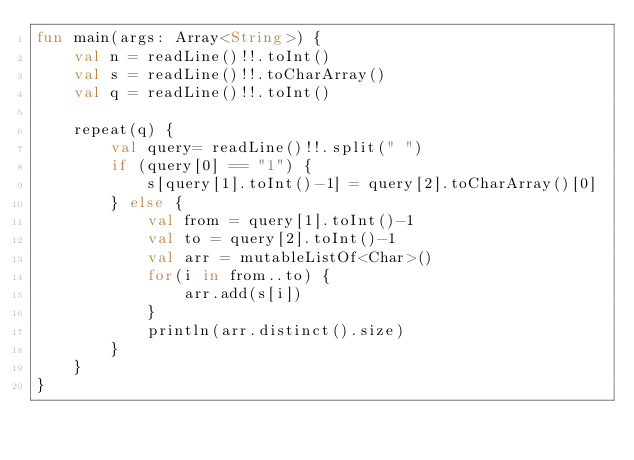Convert code to text. <code><loc_0><loc_0><loc_500><loc_500><_Kotlin_>fun main(args: Array<String>) {
    val n = readLine()!!.toInt()
    val s = readLine()!!.toCharArray()
    val q = readLine()!!.toInt()

    repeat(q) {
        val query= readLine()!!.split(" ")
        if (query[0] == "1") {
            s[query[1].toInt()-1] = query[2].toCharArray()[0]
        } else {
            val from = query[1].toInt()-1
            val to = query[2].toInt()-1
            val arr = mutableListOf<Char>()
            for(i in from..to) {
                arr.add(s[i])
            }
            println(arr.distinct().size)
        }
    }
}
</code> 